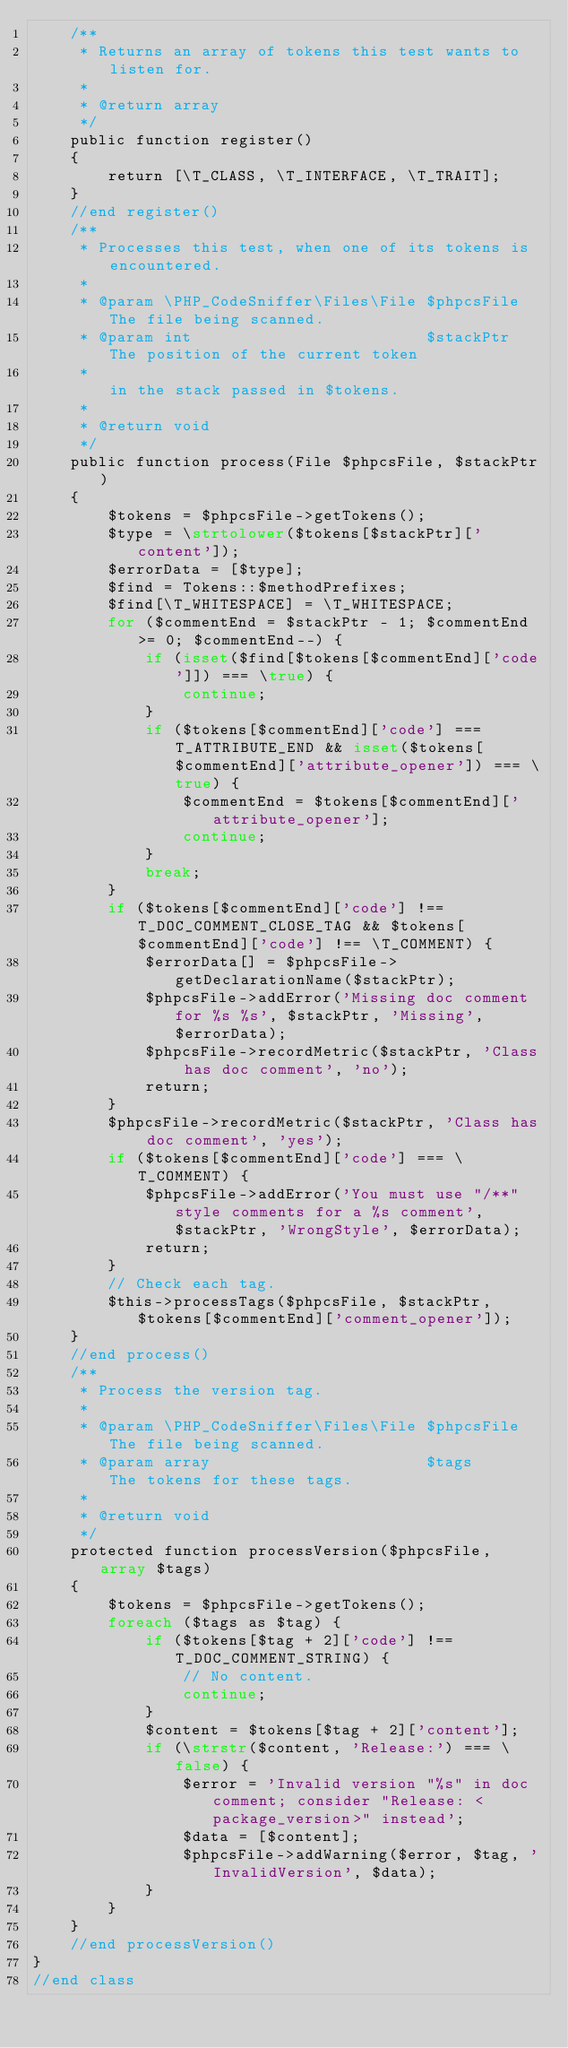Convert code to text. <code><loc_0><loc_0><loc_500><loc_500><_PHP_>    /**
     * Returns an array of tokens this test wants to listen for.
     *
     * @return array
     */
    public function register()
    {
        return [\T_CLASS, \T_INTERFACE, \T_TRAIT];
    }
    //end register()
    /**
     * Processes this test, when one of its tokens is encountered.
     *
     * @param \PHP_CodeSniffer\Files\File $phpcsFile The file being scanned.
     * @param int                         $stackPtr  The position of the current token
     *                                               in the stack passed in $tokens.
     *
     * @return void
     */
    public function process(File $phpcsFile, $stackPtr)
    {
        $tokens = $phpcsFile->getTokens();
        $type = \strtolower($tokens[$stackPtr]['content']);
        $errorData = [$type];
        $find = Tokens::$methodPrefixes;
        $find[\T_WHITESPACE] = \T_WHITESPACE;
        for ($commentEnd = $stackPtr - 1; $commentEnd >= 0; $commentEnd--) {
            if (isset($find[$tokens[$commentEnd]['code']]) === \true) {
                continue;
            }
            if ($tokens[$commentEnd]['code'] === T_ATTRIBUTE_END && isset($tokens[$commentEnd]['attribute_opener']) === \true) {
                $commentEnd = $tokens[$commentEnd]['attribute_opener'];
                continue;
            }
            break;
        }
        if ($tokens[$commentEnd]['code'] !== T_DOC_COMMENT_CLOSE_TAG && $tokens[$commentEnd]['code'] !== \T_COMMENT) {
            $errorData[] = $phpcsFile->getDeclarationName($stackPtr);
            $phpcsFile->addError('Missing doc comment for %s %s', $stackPtr, 'Missing', $errorData);
            $phpcsFile->recordMetric($stackPtr, 'Class has doc comment', 'no');
            return;
        }
        $phpcsFile->recordMetric($stackPtr, 'Class has doc comment', 'yes');
        if ($tokens[$commentEnd]['code'] === \T_COMMENT) {
            $phpcsFile->addError('You must use "/**" style comments for a %s comment', $stackPtr, 'WrongStyle', $errorData);
            return;
        }
        // Check each tag.
        $this->processTags($phpcsFile, $stackPtr, $tokens[$commentEnd]['comment_opener']);
    }
    //end process()
    /**
     * Process the version tag.
     *
     * @param \PHP_CodeSniffer\Files\File $phpcsFile The file being scanned.
     * @param array                       $tags      The tokens for these tags.
     *
     * @return void
     */
    protected function processVersion($phpcsFile, array $tags)
    {
        $tokens = $phpcsFile->getTokens();
        foreach ($tags as $tag) {
            if ($tokens[$tag + 2]['code'] !== T_DOC_COMMENT_STRING) {
                // No content.
                continue;
            }
            $content = $tokens[$tag + 2]['content'];
            if (\strstr($content, 'Release:') === \false) {
                $error = 'Invalid version "%s" in doc comment; consider "Release: <package_version>" instead';
                $data = [$content];
                $phpcsFile->addWarning($error, $tag, 'InvalidVersion', $data);
            }
        }
    }
    //end processVersion()
}
//end class
</code> 